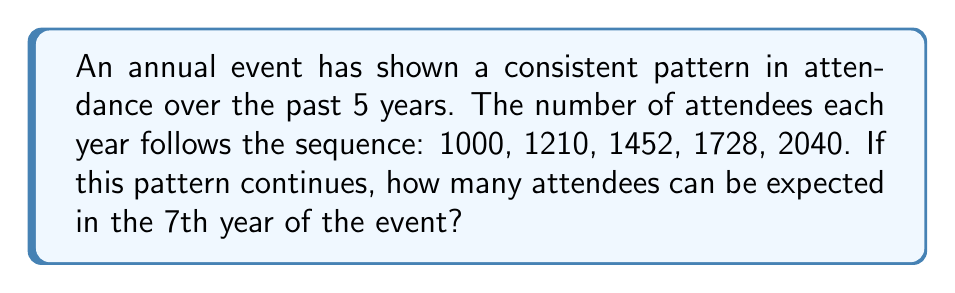Provide a solution to this math problem. To solve this problem, we need to identify the pattern in the given sequence:

1. First, let's calculate the ratio between consecutive terms:

   1210 / 1000 = 1.21
   1452 / 1210 ≈ 1.20
   1728 / 1452 ≈ 1.19
   2040 / 1728 ≈ 1.18

2. We can observe that the ratio is decreasing by 0.01 each time.

3. Let's define the general term of the sequence as $a_n$, where $n$ is the year number (starting from 1).

4. The ratio between consecutive terms can be expressed as:
   $\frac{a_{n+1}}{a_n} = 1.22 - 0.01n$

5. We can write this as a recurrence relation:
   $a_{n+1} = a_n(1.22 - 0.01n)$

6. To find the 7th year, we need to calculate $a_6$ and $a_7$:

   $a_6 = 2040(1.22 - 0.01 \cdot 5) = 2040 \cdot 1.17 = 2386.8$
   $a_7 = 2386.8(1.22 - 0.01 \cdot 6) = 2386.8 \cdot 1.16 = 2768.688$

7. Since we're dealing with people, we round down to the nearest whole number.
Answer: 2768 